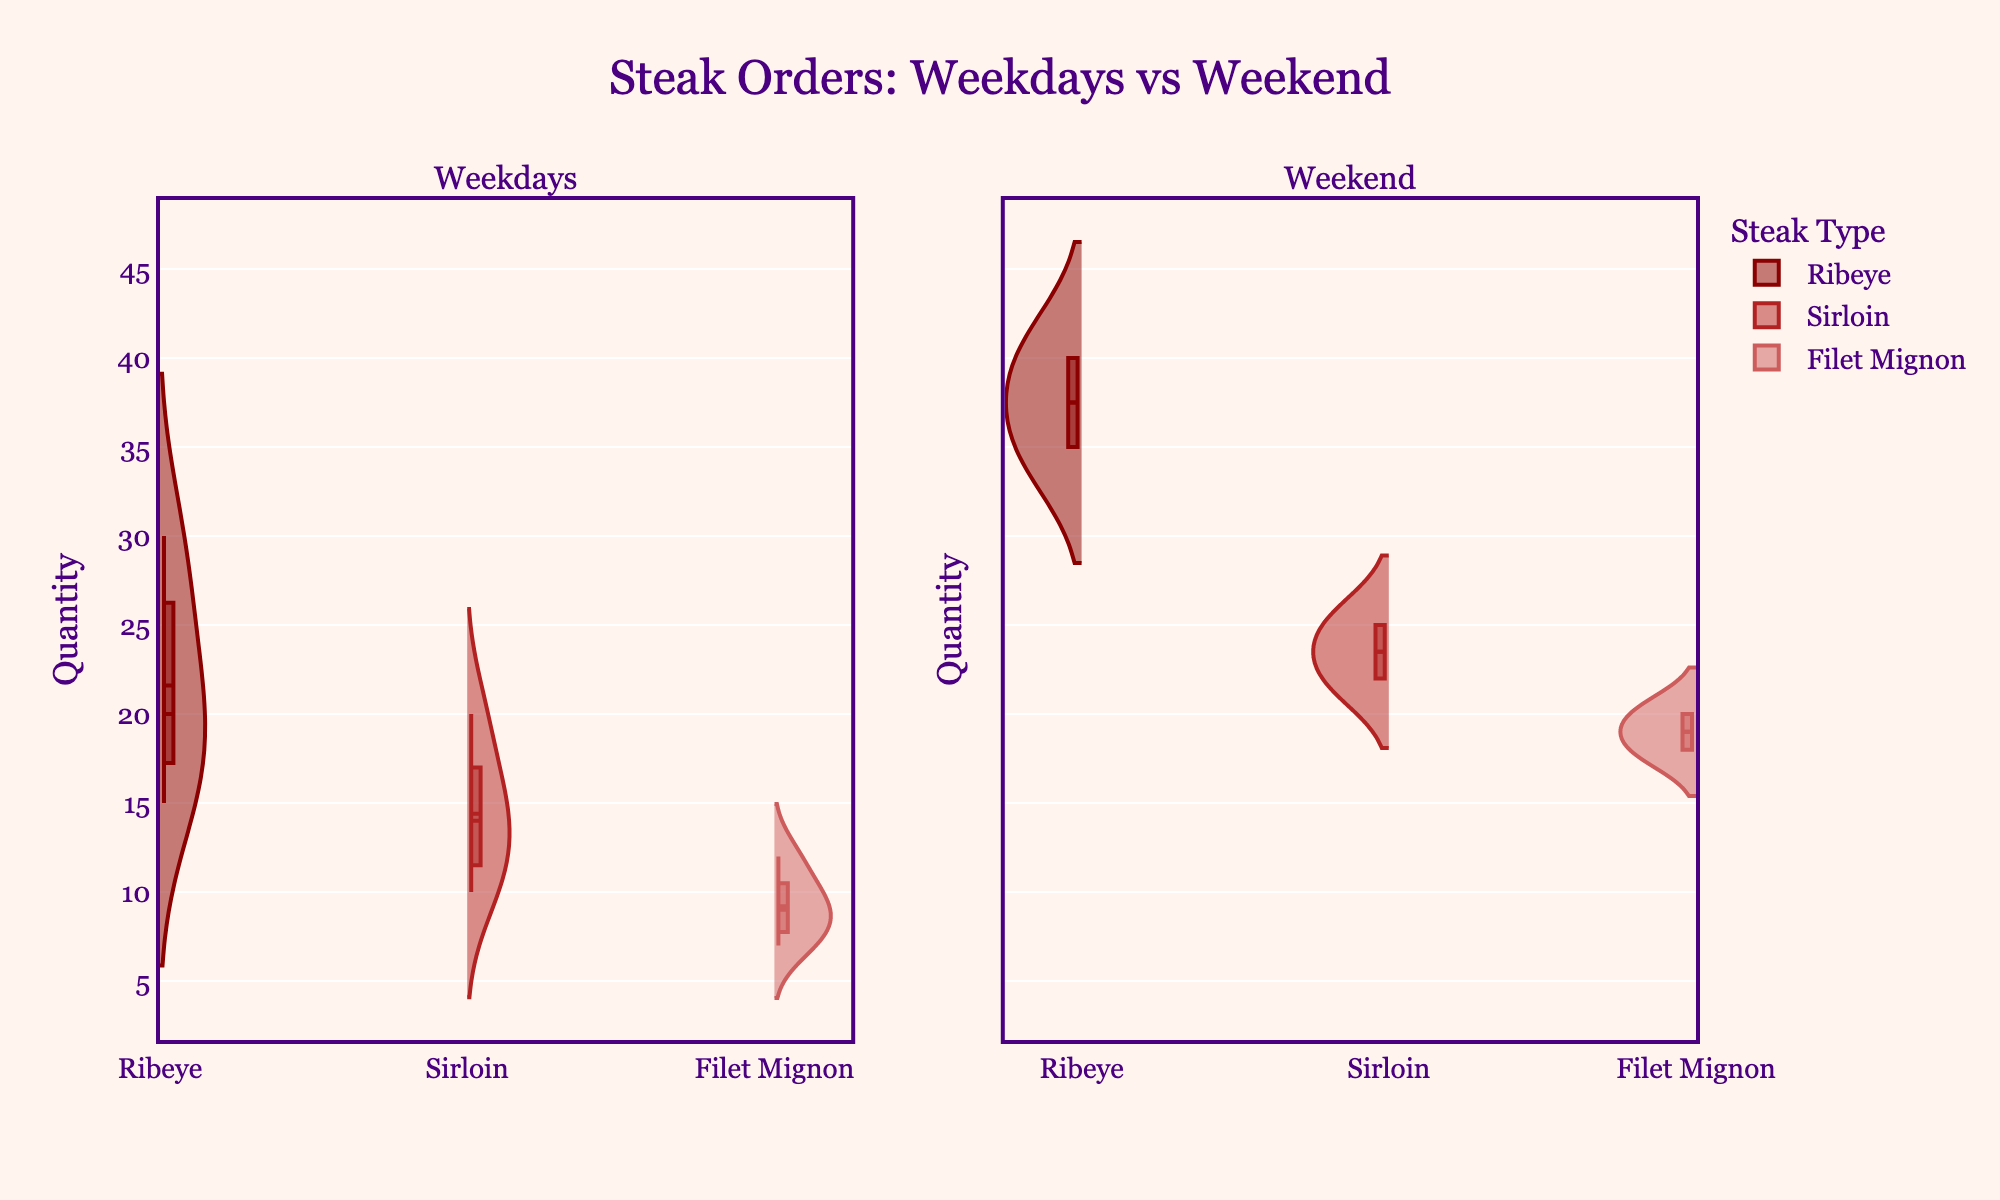What's the title of the figure? The title is usually placed at the top of the figure and often summarizes what the figure is about.
Answer: Steak Orders: Weekdays vs Weekend What are the two categories compared in the chart? The two categories are clearly labeled in the subplot titles at the top of the figure, "Weekdays" and "Weekend."
Answer: Weekdays and Weekend How many types of steaks are represented in the figure? By looking at the legend or the different sections of the violins which use different colors, we can count the unique steak types.
Answer: Three types What is the color used for Ribeye in the chart? The legend at the right of the figure often indicates what each color represents. The color for Ribeye is visible there.
Answer: Dark red Which steak type shows higher variability in order quantity on weekends? We need to compare the width distribution of each steak type on the right side (Weekend) of the chart. The one with the widest spread indicates higher variability.
Answer: Ribeye What's the average quantity of Sirloin ordered on the weekdays? Observing the position of the mean line inside the Sirloin violin plot on the left side (Weekdays) will provide this information.
Answer: Approximately 14.4 Which day shows the highest quantity of Ribeye orders within weekdays? By examining the individual points in the precise vertical spread within the Ribeye section on the left (Weekdays), the highest point indicates the highest quantity.
Answer: Thursday Comparing filet mignon orders, are they more popular on weekdays or weekends? We need to compare the general width and volume of the Filet Mignon violins between Weekdays and Weekend. The larger area will indicate higher popularity.
Answer: Weekends Which steak type has the narrowest range of order quantities on weekdays? Observing the width of the violins on the left side (Weekdays) and choosing the narrowest one will give us the answer.
Answer: Filet Mignon What’s the median quantity of Ribeye ordered on weekends? The median line in the Ribeye section on the right side (Weekend) of the chart will give this information.
Answer: Approximately 37.5 